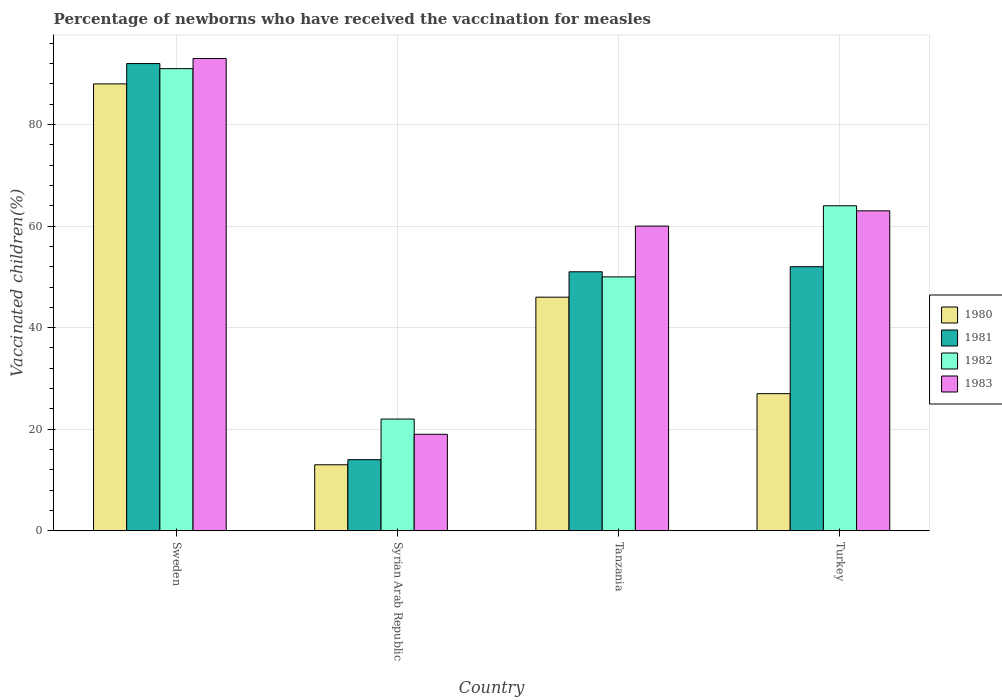How many different coloured bars are there?
Offer a terse response. 4. How many groups of bars are there?
Your response must be concise. 4. Are the number of bars on each tick of the X-axis equal?
Give a very brief answer. Yes. How many bars are there on the 4th tick from the left?
Ensure brevity in your answer.  4. How many bars are there on the 1st tick from the right?
Your response must be concise. 4. What is the label of the 4th group of bars from the left?
Keep it short and to the point. Turkey. What is the percentage of vaccinated children in 1982 in Sweden?
Provide a short and direct response. 91. Across all countries, what is the maximum percentage of vaccinated children in 1981?
Offer a very short reply. 92. Across all countries, what is the minimum percentage of vaccinated children in 1982?
Offer a terse response. 22. In which country was the percentage of vaccinated children in 1982 maximum?
Ensure brevity in your answer.  Sweden. In which country was the percentage of vaccinated children in 1981 minimum?
Your response must be concise. Syrian Arab Republic. What is the total percentage of vaccinated children in 1983 in the graph?
Keep it short and to the point. 235. What is the average percentage of vaccinated children in 1982 per country?
Keep it short and to the point. 56.75. What is the difference between the percentage of vaccinated children of/in 1983 and percentage of vaccinated children of/in 1982 in Sweden?
Offer a very short reply. 2. In how many countries, is the percentage of vaccinated children in 1981 greater than 4 %?
Provide a short and direct response. 4. What is the ratio of the percentage of vaccinated children in 1981 in Sweden to that in Syrian Arab Republic?
Provide a succinct answer. 6.57. Is the percentage of vaccinated children in 1980 in Sweden less than that in Syrian Arab Republic?
Make the answer very short. No. Is the difference between the percentage of vaccinated children in 1983 in Syrian Arab Republic and Turkey greater than the difference between the percentage of vaccinated children in 1982 in Syrian Arab Republic and Turkey?
Your answer should be compact. No. What is the difference between the highest and the second highest percentage of vaccinated children in 1981?
Your answer should be very brief. -41. In how many countries, is the percentage of vaccinated children in 1982 greater than the average percentage of vaccinated children in 1982 taken over all countries?
Give a very brief answer. 2. What does the 4th bar from the left in Syrian Arab Republic represents?
Your answer should be very brief. 1983. Is it the case that in every country, the sum of the percentage of vaccinated children in 1981 and percentage of vaccinated children in 1980 is greater than the percentage of vaccinated children in 1982?
Ensure brevity in your answer.  Yes. Does the graph contain grids?
Your answer should be very brief. Yes. Where does the legend appear in the graph?
Ensure brevity in your answer.  Center right. How many legend labels are there?
Your answer should be very brief. 4. What is the title of the graph?
Your response must be concise. Percentage of newborns who have received the vaccination for measles. What is the label or title of the Y-axis?
Your answer should be compact. Vaccinated children(%). What is the Vaccinated children(%) of 1981 in Sweden?
Provide a short and direct response. 92. What is the Vaccinated children(%) of 1982 in Sweden?
Make the answer very short. 91. What is the Vaccinated children(%) of 1983 in Sweden?
Provide a short and direct response. 93. What is the Vaccinated children(%) of 1980 in Tanzania?
Provide a short and direct response. 46. What is the Vaccinated children(%) in 1981 in Tanzania?
Ensure brevity in your answer.  51. What is the Vaccinated children(%) of 1982 in Tanzania?
Your answer should be compact. 50. What is the Vaccinated children(%) in 1980 in Turkey?
Keep it short and to the point. 27. What is the Vaccinated children(%) in 1981 in Turkey?
Offer a terse response. 52. What is the Vaccinated children(%) of 1982 in Turkey?
Provide a succinct answer. 64. What is the Vaccinated children(%) of 1983 in Turkey?
Your answer should be compact. 63. Across all countries, what is the maximum Vaccinated children(%) of 1981?
Provide a short and direct response. 92. Across all countries, what is the maximum Vaccinated children(%) of 1982?
Make the answer very short. 91. Across all countries, what is the maximum Vaccinated children(%) in 1983?
Keep it short and to the point. 93. Across all countries, what is the minimum Vaccinated children(%) of 1981?
Offer a very short reply. 14. Across all countries, what is the minimum Vaccinated children(%) in 1983?
Provide a succinct answer. 19. What is the total Vaccinated children(%) of 1980 in the graph?
Your answer should be very brief. 174. What is the total Vaccinated children(%) of 1981 in the graph?
Offer a terse response. 209. What is the total Vaccinated children(%) of 1982 in the graph?
Provide a short and direct response. 227. What is the total Vaccinated children(%) in 1983 in the graph?
Provide a succinct answer. 235. What is the difference between the Vaccinated children(%) of 1982 in Sweden and that in Syrian Arab Republic?
Ensure brevity in your answer.  69. What is the difference between the Vaccinated children(%) in 1980 in Sweden and that in Tanzania?
Ensure brevity in your answer.  42. What is the difference between the Vaccinated children(%) of 1981 in Sweden and that in Tanzania?
Your response must be concise. 41. What is the difference between the Vaccinated children(%) in 1982 in Sweden and that in Tanzania?
Your answer should be compact. 41. What is the difference between the Vaccinated children(%) in 1983 in Sweden and that in Tanzania?
Your answer should be compact. 33. What is the difference between the Vaccinated children(%) in 1983 in Sweden and that in Turkey?
Give a very brief answer. 30. What is the difference between the Vaccinated children(%) of 1980 in Syrian Arab Republic and that in Tanzania?
Keep it short and to the point. -33. What is the difference between the Vaccinated children(%) of 1981 in Syrian Arab Republic and that in Tanzania?
Ensure brevity in your answer.  -37. What is the difference between the Vaccinated children(%) of 1982 in Syrian Arab Republic and that in Tanzania?
Provide a succinct answer. -28. What is the difference between the Vaccinated children(%) in 1983 in Syrian Arab Republic and that in Tanzania?
Your answer should be compact. -41. What is the difference between the Vaccinated children(%) of 1980 in Syrian Arab Republic and that in Turkey?
Your response must be concise. -14. What is the difference between the Vaccinated children(%) in 1981 in Syrian Arab Republic and that in Turkey?
Give a very brief answer. -38. What is the difference between the Vaccinated children(%) in 1982 in Syrian Arab Republic and that in Turkey?
Provide a succinct answer. -42. What is the difference between the Vaccinated children(%) of 1983 in Syrian Arab Republic and that in Turkey?
Provide a succinct answer. -44. What is the difference between the Vaccinated children(%) of 1980 in Tanzania and that in Turkey?
Make the answer very short. 19. What is the difference between the Vaccinated children(%) of 1981 in Tanzania and that in Turkey?
Keep it short and to the point. -1. What is the difference between the Vaccinated children(%) in 1983 in Tanzania and that in Turkey?
Your response must be concise. -3. What is the difference between the Vaccinated children(%) in 1981 in Sweden and the Vaccinated children(%) in 1982 in Syrian Arab Republic?
Make the answer very short. 70. What is the difference between the Vaccinated children(%) of 1981 in Sweden and the Vaccinated children(%) of 1983 in Syrian Arab Republic?
Keep it short and to the point. 73. What is the difference between the Vaccinated children(%) in 1982 in Sweden and the Vaccinated children(%) in 1983 in Syrian Arab Republic?
Provide a succinct answer. 72. What is the difference between the Vaccinated children(%) in 1980 in Sweden and the Vaccinated children(%) in 1981 in Tanzania?
Make the answer very short. 37. What is the difference between the Vaccinated children(%) of 1981 in Sweden and the Vaccinated children(%) of 1982 in Tanzania?
Your answer should be very brief. 42. What is the difference between the Vaccinated children(%) in 1981 in Sweden and the Vaccinated children(%) in 1983 in Tanzania?
Keep it short and to the point. 32. What is the difference between the Vaccinated children(%) of 1982 in Sweden and the Vaccinated children(%) of 1983 in Tanzania?
Your answer should be very brief. 31. What is the difference between the Vaccinated children(%) of 1980 in Sweden and the Vaccinated children(%) of 1982 in Turkey?
Provide a succinct answer. 24. What is the difference between the Vaccinated children(%) in 1980 in Sweden and the Vaccinated children(%) in 1983 in Turkey?
Offer a very short reply. 25. What is the difference between the Vaccinated children(%) in 1981 in Sweden and the Vaccinated children(%) in 1982 in Turkey?
Ensure brevity in your answer.  28. What is the difference between the Vaccinated children(%) in 1981 in Sweden and the Vaccinated children(%) in 1983 in Turkey?
Your answer should be compact. 29. What is the difference between the Vaccinated children(%) in 1982 in Sweden and the Vaccinated children(%) in 1983 in Turkey?
Provide a short and direct response. 28. What is the difference between the Vaccinated children(%) in 1980 in Syrian Arab Republic and the Vaccinated children(%) in 1981 in Tanzania?
Your answer should be very brief. -38. What is the difference between the Vaccinated children(%) in 1980 in Syrian Arab Republic and the Vaccinated children(%) in 1982 in Tanzania?
Provide a succinct answer. -37. What is the difference between the Vaccinated children(%) in 1980 in Syrian Arab Republic and the Vaccinated children(%) in 1983 in Tanzania?
Offer a terse response. -47. What is the difference between the Vaccinated children(%) of 1981 in Syrian Arab Republic and the Vaccinated children(%) of 1982 in Tanzania?
Provide a short and direct response. -36. What is the difference between the Vaccinated children(%) in 1981 in Syrian Arab Republic and the Vaccinated children(%) in 1983 in Tanzania?
Your response must be concise. -46. What is the difference between the Vaccinated children(%) of 1982 in Syrian Arab Republic and the Vaccinated children(%) of 1983 in Tanzania?
Provide a succinct answer. -38. What is the difference between the Vaccinated children(%) in 1980 in Syrian Arab Republic and the Vaccinated children(%) in 1981 in Turkey?
Offer a terse response. -39. What is the difference between the Vaccinated children(%) of 1980 in Syrian Arab Republic and the Vaccinated children(%) of 1982 in Turkey?
Make the answer very short. -51. What is the difference between the Vaccinated children(%) in 1980 in Syrian Arab Republic and the Vaccinated children(%) in 1983 in Turkey?
Keep it short and to the point. -50. What is the difference between the Vaccinated children(%) in 1981 in Syrian Arab Republic and the Vaccinated children(%) in 1982 in Turkey?
Your answer should be very brief. -50. What is the difference between the Vaccinated children(%) in 1981 in Syrian Arab Republic and the Vaccinated children(%) in 1983 in Turkey?
Your answer should be very brief. -49. What is the difference between the Vaccinated children(%) in 1982 in Syrian Arab Republic and the Vaccinated children(%) in 1983 in Turkey?
Ensure brevity in your answer.  -41. What is the difference between the Vaccinated children(%) in 1980 in Tanzania and the Vaccinated children(%) in 1981 in Turkey?
Provide a short and direct response. -6. What is the difference between the Vaccinated children(%) in 1980 in Tanzania and the Vaccinated children(%) in 1982 in Turkey?
Your response must be concise. -18. What is the difference between the Vaccinated children(%) in 1980 in Tanzania and the Vaccinated children(%) in 1983 in Turkey?
Provide a succinct answer. -17. What is the average Vaccinated children(%) of 1980 per country?
Offer a very short reply. 43.5. What is the average Vaccinated children(%) in 1981 per country?
Ensure brevity in your answer.  52.25. What is the average Vaccinated children(%) in 1982 per country?
Ensure brevity in your answer.  56.75. What is the average Vaccinated children(%) of 1983 per country?
Your answer should be compact. 58.75. What is the difference between the Vaccinated children(%) of 1980 and Vaccinated children(%) of 1981 in Sweden?
Provide a succinct answer. -4. What is the difference between the Vaccinated children(%) in 1980 and Vaccinated children(%) in 1982 in Sweden?
Offer a terse response. -3. What is the difference between the Vaccinated children(%) of 1980 and Vaccinated children(%) of 1983 in Sweden?
Your response must be concise. -5. What is the difference between the Vaccinated children(%) in 1981 and Vaccinated children(%) in 1982 in Sweden?
Provide a succinct answer. 1. What is the difference between the Vaccinated children(%) of 1981 and Vaccinated children(%) of 1983 in Syrian Arab Republic?
Keep it short and to the point. -5. What is the difference between the Vaccinated children(%) in 1982 and Vaccinated children(%) in 1983 in Syrian Arab Republic?
Ensure brevity in your answer.  3. What is the difference between the Vaccinated children(%) of 1981 and Vaccinated children(%) of 1982 in Tanzania?
Make the answer very short. 1. What is the difference between the Vaccinated children(%) in 1981 and Vaccinated children(%) in 1983 in Tanzania?
Your response must be concise. -9. What is the difference between the Vaccinated children(%) of 1982 and Vaccinated children(%) of 1983 in Tanzania?
Your answer should be very brief. -10. What is the difference between the Vaccinated children(%) of 1980 and Vaccinated children(%) of 1982 in Turkey?
Your response must be concise. -37. What is the difference between the Vaccinated children(%) in 1980 and Vaccinated children(%) in 1983 in Turkey?
Offer a terse response. -36. What is the difference between the Vaccinated children(%) of 1981 and Vaccinated children(%) of 1982 in Turkey?
Provide a short and direct response. -12. What is the difference between the Vaccinated children(%) in 1981 and Vaccinated children(%) in 1983 in Turkey?
Provide a succinct answer. -11. What is the ratio of the Vaccinated children(%) of 1980 in Sweden to that in Syrian Arab Republic?
Your answer should be compact. 6.77. What is the ratio of the Vaccinated children(%) of 1981 in Sweden to that in Syrian Arab Republic?
Keep it short and to the point. 6.57. What is the ratio of the Vaccinated children(%) in 1982 in Sweden to that in Syrian Arab Republic?
Provide a short and direct response. 4.14. What is the ratio of the Vaccinated children(%) of 1983 in Sweden to that in Syrian Arab Republic?
Your response must be concise. 4.89. What is the ratio of the Vaccinated children(%) in 1980 in Sweden to that in Tanzania?
Give a very brief answer. 1.91. What is the ratio of the Vaccinated children(%) of 1981 in Sweden to that in Tanzania?
Provide a short and direct response. 1.8. What is the ratio of the Vaccinated children(%) in 1982 in Sweden to that in Tanzania?
Your response must be concise. 1.82. What is the ratio of the Vaccinated children(%) of 1983 in Sweden to that in Tanzania?
Your answer should be very brief. 1.55. What is the ratio of the Vaccinated children(%) in 1980 in Sweden to that in Turkey?
Offer a very short reply. 3.26. What is the ratio of the Vaccinated children(%) in 1981 in Sweden to that in Turkey?
Ensure brevity in your answer.  1.77. What is the ratio of the Vaccinated children(%) of 1982 in Sweden to that in Turkey?
Provide a short and direct response. 1.42. What is the ratio of the Vaccinated children(%) in 1983 in Sweden to that in Turkey?
Your answer should be very brief. 1.48. What is the ratio of the Vaccinated children(%) in 1980 in Syrian Arab Republic to that in Tanzania?
Ensure brevity in your answer.  0.28. What is the ratio of the Vaccinated children(%) in 1981 in Syrian Arab Republic to that in Tanzania?
Your answer should be compact. 0.27. What is the ratio of the Vaccinated children(%) in 1982 in Syrian Arab Republic to that in Tanzania?
Your response must be concise. 0.44. What is the ratio of the Vaccinated children(%) of 1983 in Syrian Arab Republic to that in Tanzania?
Keep it short and to the point. 0.32. What is the ratio of the Vaccinated children(%) in 1980 in Syrian Arab Republic to that in Turkey?
Your answer should be compact. 0.48. What is the ratio of the Vaccinated children(%) of 1981 in Syrian Arab Republic to that in Turkey?
Ensure brevity in your answer.  0.27. What is the ratio of the Vaccinated children(%) in 1982 in Syrian Arab Republic to that in Turkey?
Your answer should be very brief. 0.34. What is the ratio of the Vaccinated children(%) of 1983 in Syrian Arab Republic to that in Turkey?
Your answer should be compact. 0.3. What is the ratio of the Vaccinated children(%) in 1980 in Tanzania to that in Turkey?
Offer a very short reply. 1.7. What is the ratio of the Vaccinated children(%) of 1981 in Tanzania to that in Turkey?
Offer a very short reply. 0.98. What is the ratio of the Vaccinated children(%) of 1982 in Tanzania to that in Turkey?
Offer a very short reply. 0.78. What is the ratio of the Vaccinated children(%) in 1983 in Tanzania to that in Turkey?
Give a very brief answer. 0.95. What is the difference between the highest and the second highest Vaccinated children(%) in 1981?
Offer a terse response. 40. What is the difference between the highest and the second highest Vaccinated children(%) of 1982?
Your response must be concise. 27. What is the difference between the highest and the lowest Vaccinated children(%) in 1981?
Provide a succinct answer. 78. What is the difference between the highest and the lowest Vaccinated children(%) in 1982?
Make the answer very short. 69. What is the difference between the highest and the lowest Vaccinated children(%) in 1983?
Keep it short and to the point. 74. 